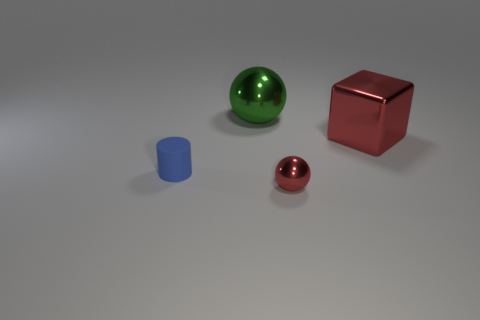How big is the object that is in front of the cube and behind the small ball? The object in front of the cube and behind the small ball is a cylindrical shape that appears to be roughly twice as tall as the small ball in front of it, with a diameter that is comparable to its height. 